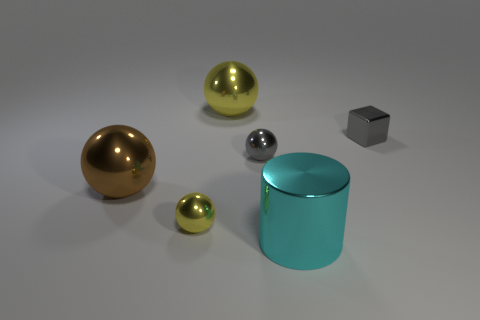Add 1 small yellow shiny blocks. How many objects exist? 7 Subtract all cubes. How many objects are left? 5 Add 6 small red rubber spheres. How many small red rubber spheres exist? 6 Subtract 0 green balls. How many objects are left? 6 Subtract all red rubber objects. Subtract all big yellow shiny objects. How many objects are left? 5 Add 5 big cyan metallic things. How many big cyan metallic things are left? 6 